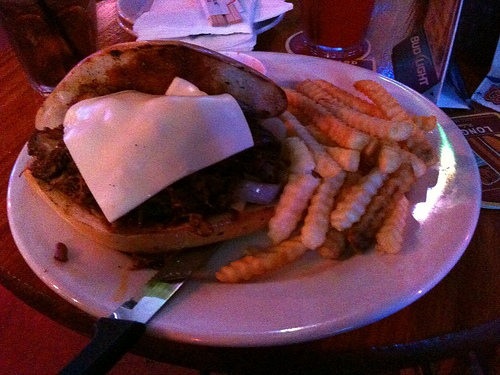Please extract the text content from this image. BUD LIGHT 